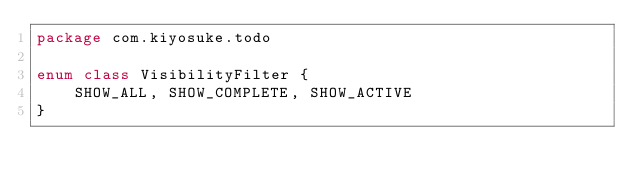<code> <loc_0><loc_0><loc_500><loc_500><_Kotlin_>package com.kiyosuke.todo

enum class VisibilityFilter {
    SHOW_ALL, SHOW_COMPLETE, SHOW_ACTIVE
}</code> 